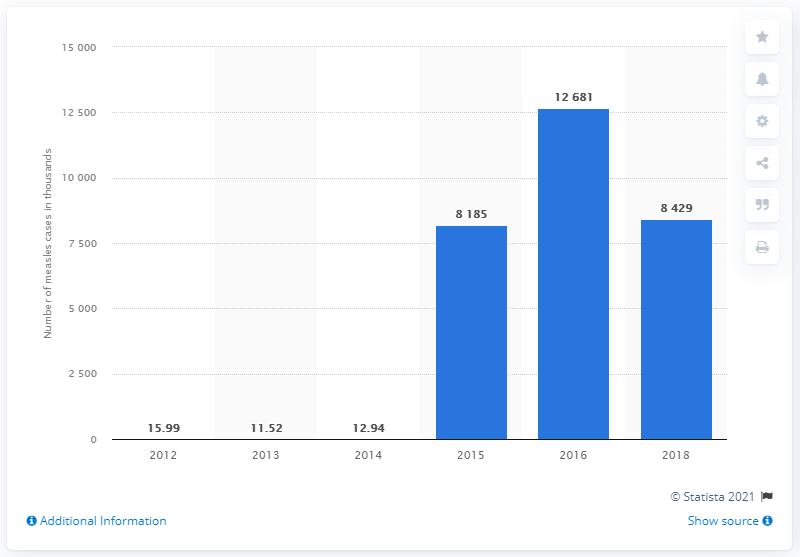Specify some key components in this picture. In 2018, a total of 8,429 cases of measles were reported in Indonesia. 